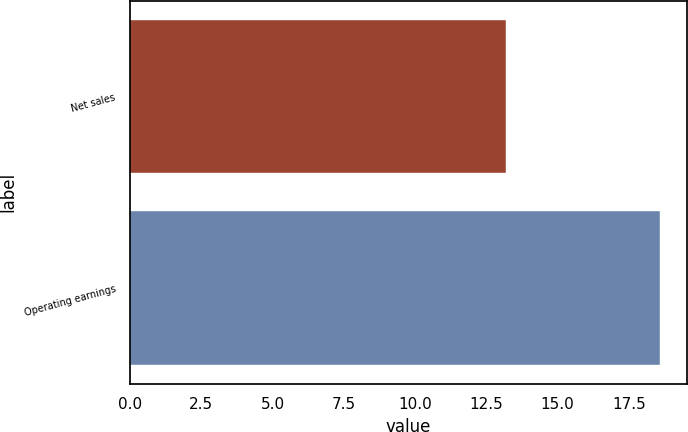<chart> <loc_0><loc_0><loc_500><loc_500><bar_chart><fcel>Net sales<fcel>Operating earnings<nl><fcel>13.2<fcel>18.6<nl></chart> 